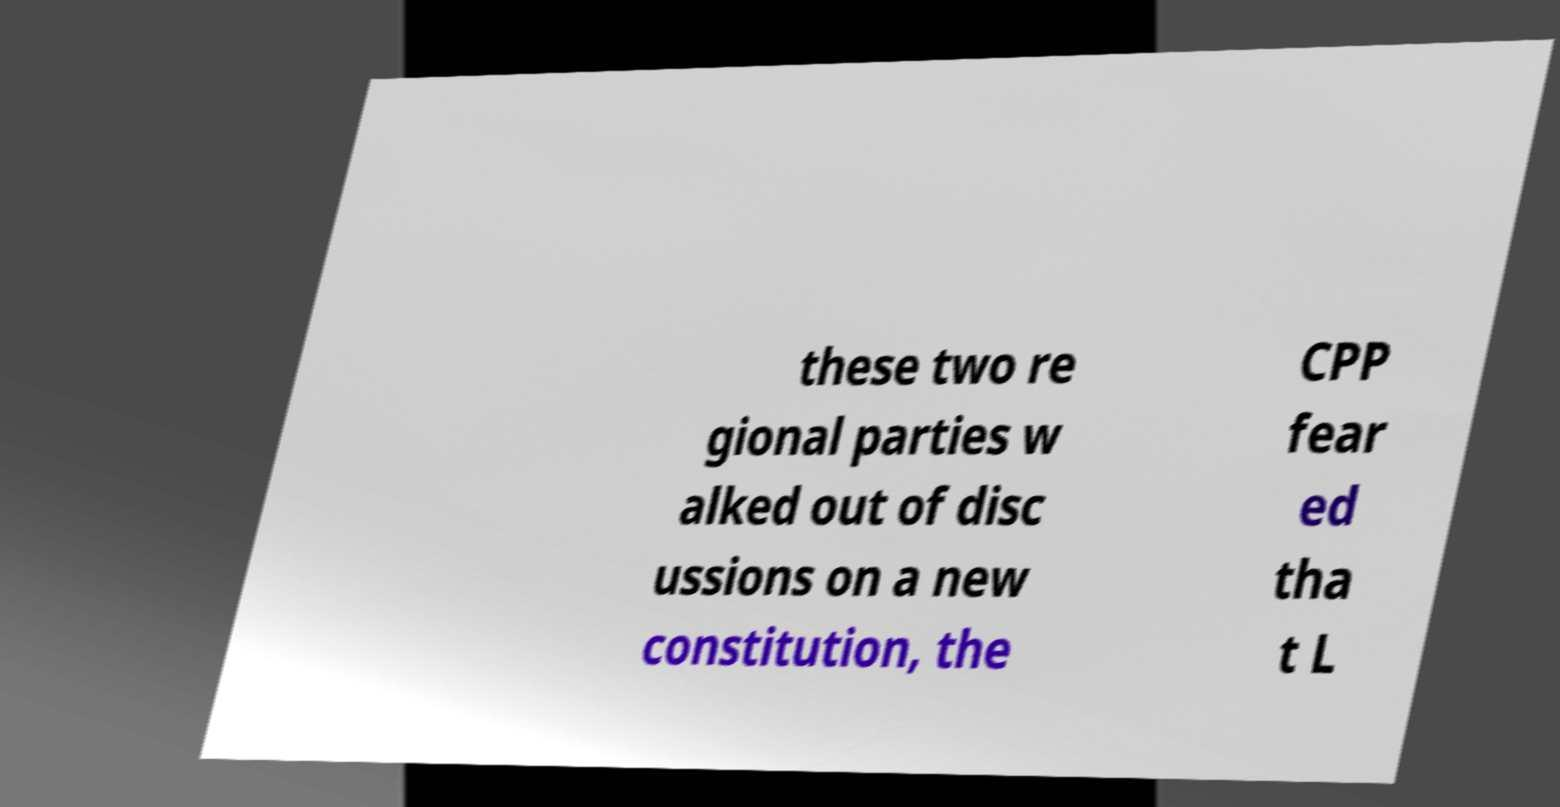Can you accurately transcribe the text from the provided image for me? these two re gional parties w alked out of disc ussions on a new constitution, the CPP fear ed tha t L 